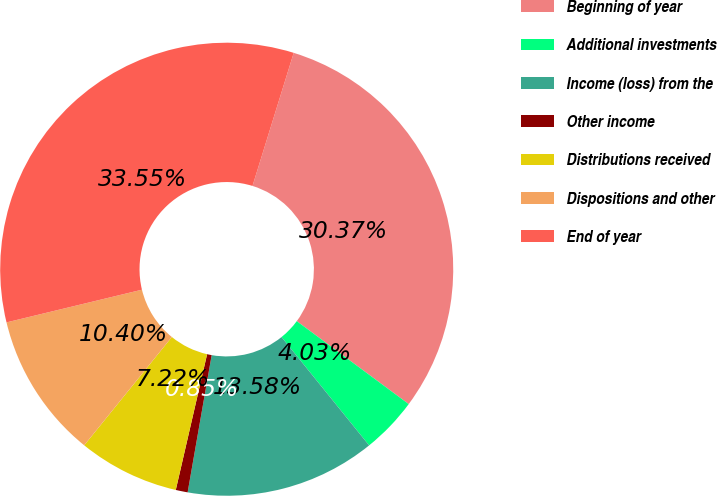Convert chart to OTSL. <chart><loc_0><loc_0><loc_500><loc_500><pie_chart><fcel>Beginning of year<fcel>Additional investments<fcel>Income (loss) from the<fcel>Other income<fcel>Distributions received<fcel>Dispositions and other<fcel>End of year<nl><fcel>30.37%<fcel>4.03%<fcel>13.58%<fcel>0.85%<fcel>7.22%<fcel>10.4%<fcel>33.55%<nl></chart> 